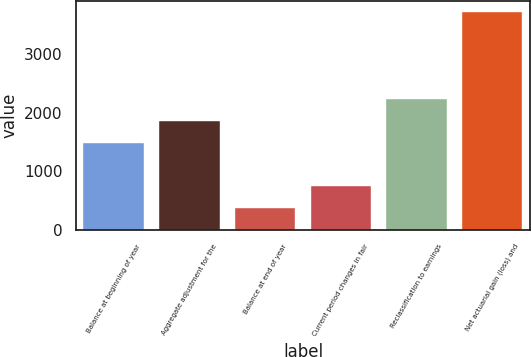Convert chart. <chart><loc_0><loc_0><loc_500><loc_500><bar_chart><fcel>Balance at beginning of year<fcel>Aggregate adjustment for the<fcel>Balance at end of year<fcel>Current period changes in fair<fcel>Reclassification to earnings<fcel>Net actuarial gain (loss) and<nl><fcel>1492.2<fcel>1863<fcel>379.8<fcel>750.6<fcel>2233.8<fcel>3717<nl></chart> 